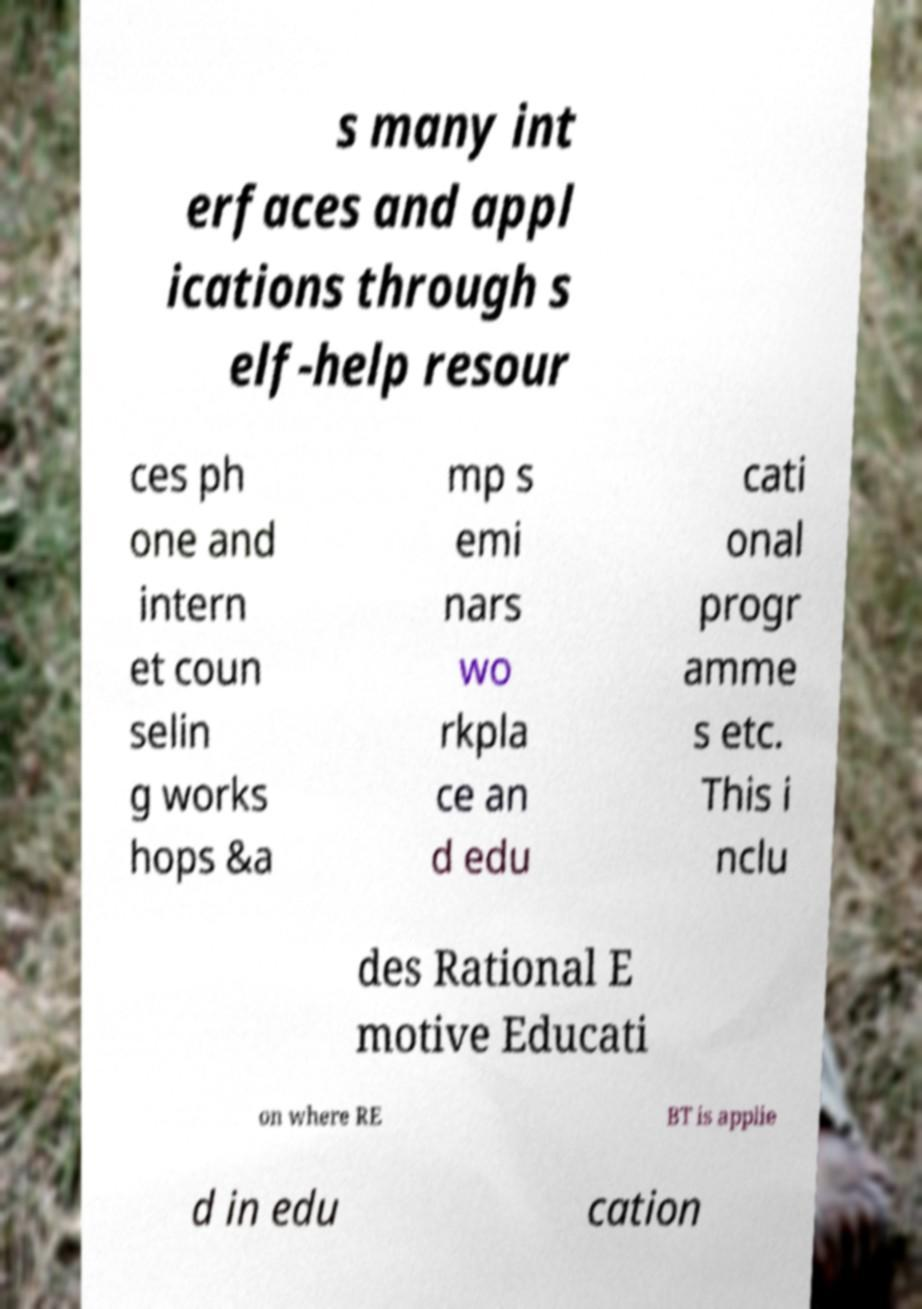There's text embedded in this image that I need extracted. Can you transcribe it verbatim? s many int erfaces and appl ications through s elf-help resour ces ph one and intern et coun selin g works hops &a mp s emi nars wo rkpla ce an d edu cati onal progr amme s etc. This i nclu des Rational E motive Educati on where RE BT is applie d in edu cation 